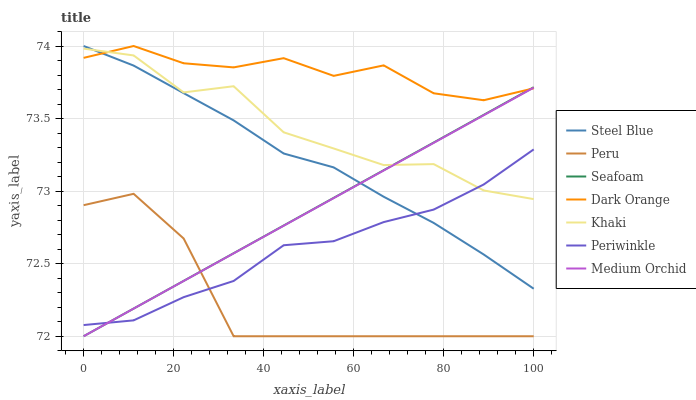Does Peru have the minimum area under the curve?
Answer yes or no. Yes. Does Dark Orange have the maximum area under the curve?
Answer yes or no. Yes. Does Khaki have the minimum area under the curve?
Answer yes or no. No. Does Khaki have the maximum area under the curve?
Answer yes or no. No. Is Seafoam the smoothest?
Answer yes or no. Yes. Is Khaki the roughest?
Answer yes or no. Yes. Is Medium Orchid the smoothest?
Answer yes or no. No. Is Medium Orchid the roughest?
Answer yes or no. No. Does Medium Orchid have the lowest value?
Answer yes or no. Yes. Does Khaki have the lowest value?
Answer yes or no. No. Does Steel Blue have the highest value?
Answer yes or no. Yes. Does Khaki have the highest value?
Answer yes or no. No. Is Peru less than Dark Orange?
Answer yes or no. Yes. Is Steel Blue greater than Peru?
Answer yes or no. Yes. Does Peru intersect Periwinkle?
Answer yes or no. Yes. Is Peru less than Periwinkle?
Answer yes or no. No. Is Peru greater than Periwinkle?
Answer yes or no. No. Does Peru intersect Dark Orange?
Answer yes or no. No. 